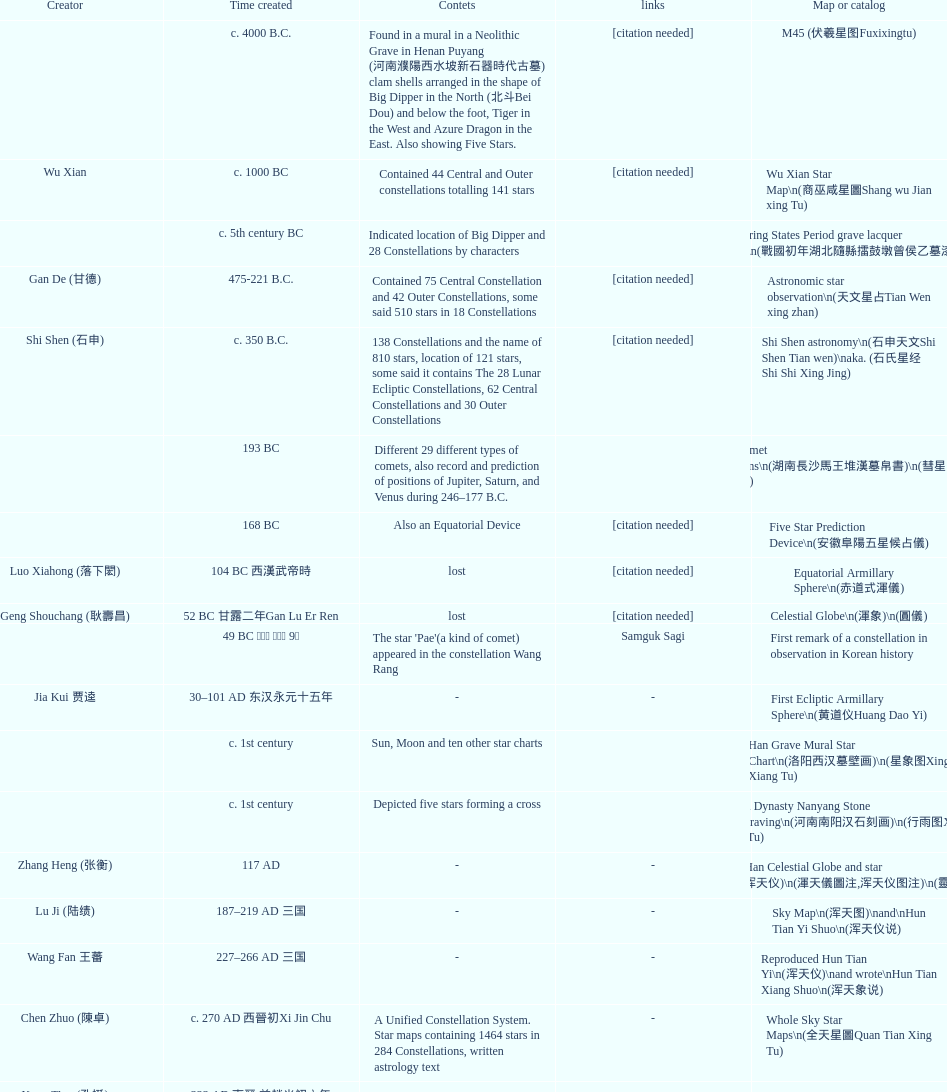Which map or catalog was created last? Sky in Google Earth KML. 